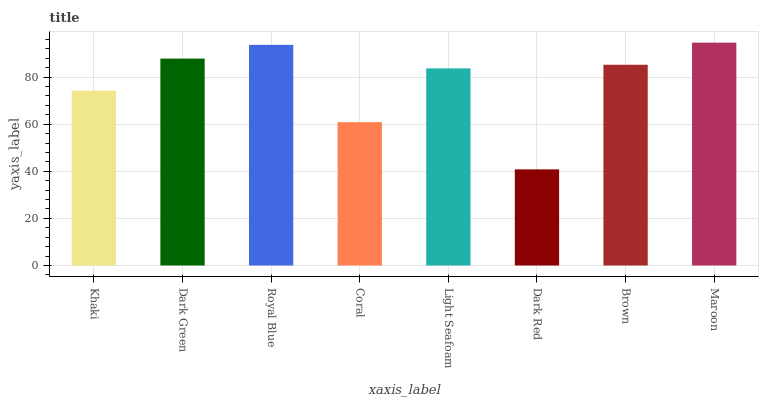Is Dark Green the minimum?
Answer yes or no. No. Is Dark Green the maximum?
Answer yes or no. No. Is Dark Green greater than Khaki?
Answer yes or no. Yes. Is Khaki less than Dark Green?
Answer yes or no. Yes. Is Khaki greater than Dark Green?
Answer yes or no. No. Is Dark Green less than Khaki?
Answer yes or no. No. Is Brown the high median?
Answer yes or no. Yes. Is Light Seafoam the low median?
Answer yes or no. Yes. Is Khaki the high median?
Answer yes or no. No. Is Royal Blue the low median?
Answer yes or no. No. 